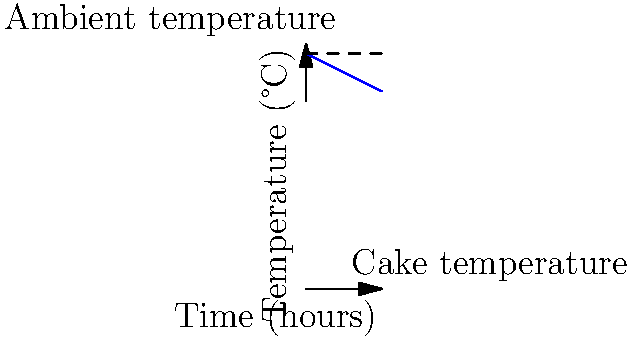For a basketball-themed wedding cake, you need to maintain its temperature between 22°C and 25°C. The ambient temperature is constant at 25°C, and the cake's temperature decreases linearly at a rate of 0.5°C per hour without intervention. What is the maximum time interval (in hours) between temperature adjustments to keep the cake within the desired range? Let's approach this step-by-step:

1) The initial temperature of the cake is 25°C (same as ambient).

2) The temperature decrease is linear at 0.5°C per hour.

3) We need to find how long it takes for the temperature to drop from 25°C to 22°C.

4) We can use the linear equation:
   $T = T_0 - rt$
   Where:
   $T$ is the final temperature (22°C)
   $T_0$ is the initial temperature (25°C)
   $r$ is the rate of temperature decrease (0.5°C/hour)
   $t$ is the time (what we're solving for)

5) Plugging in the values:
   $22 = 25 - 0.5t$

6) Solving for $t$:
   $-3 = -0.5t$
   $t = 6$ hours

Therefore, the maximum time interval between temperature adjustments is 6 hours.
Answer: 6 hours 